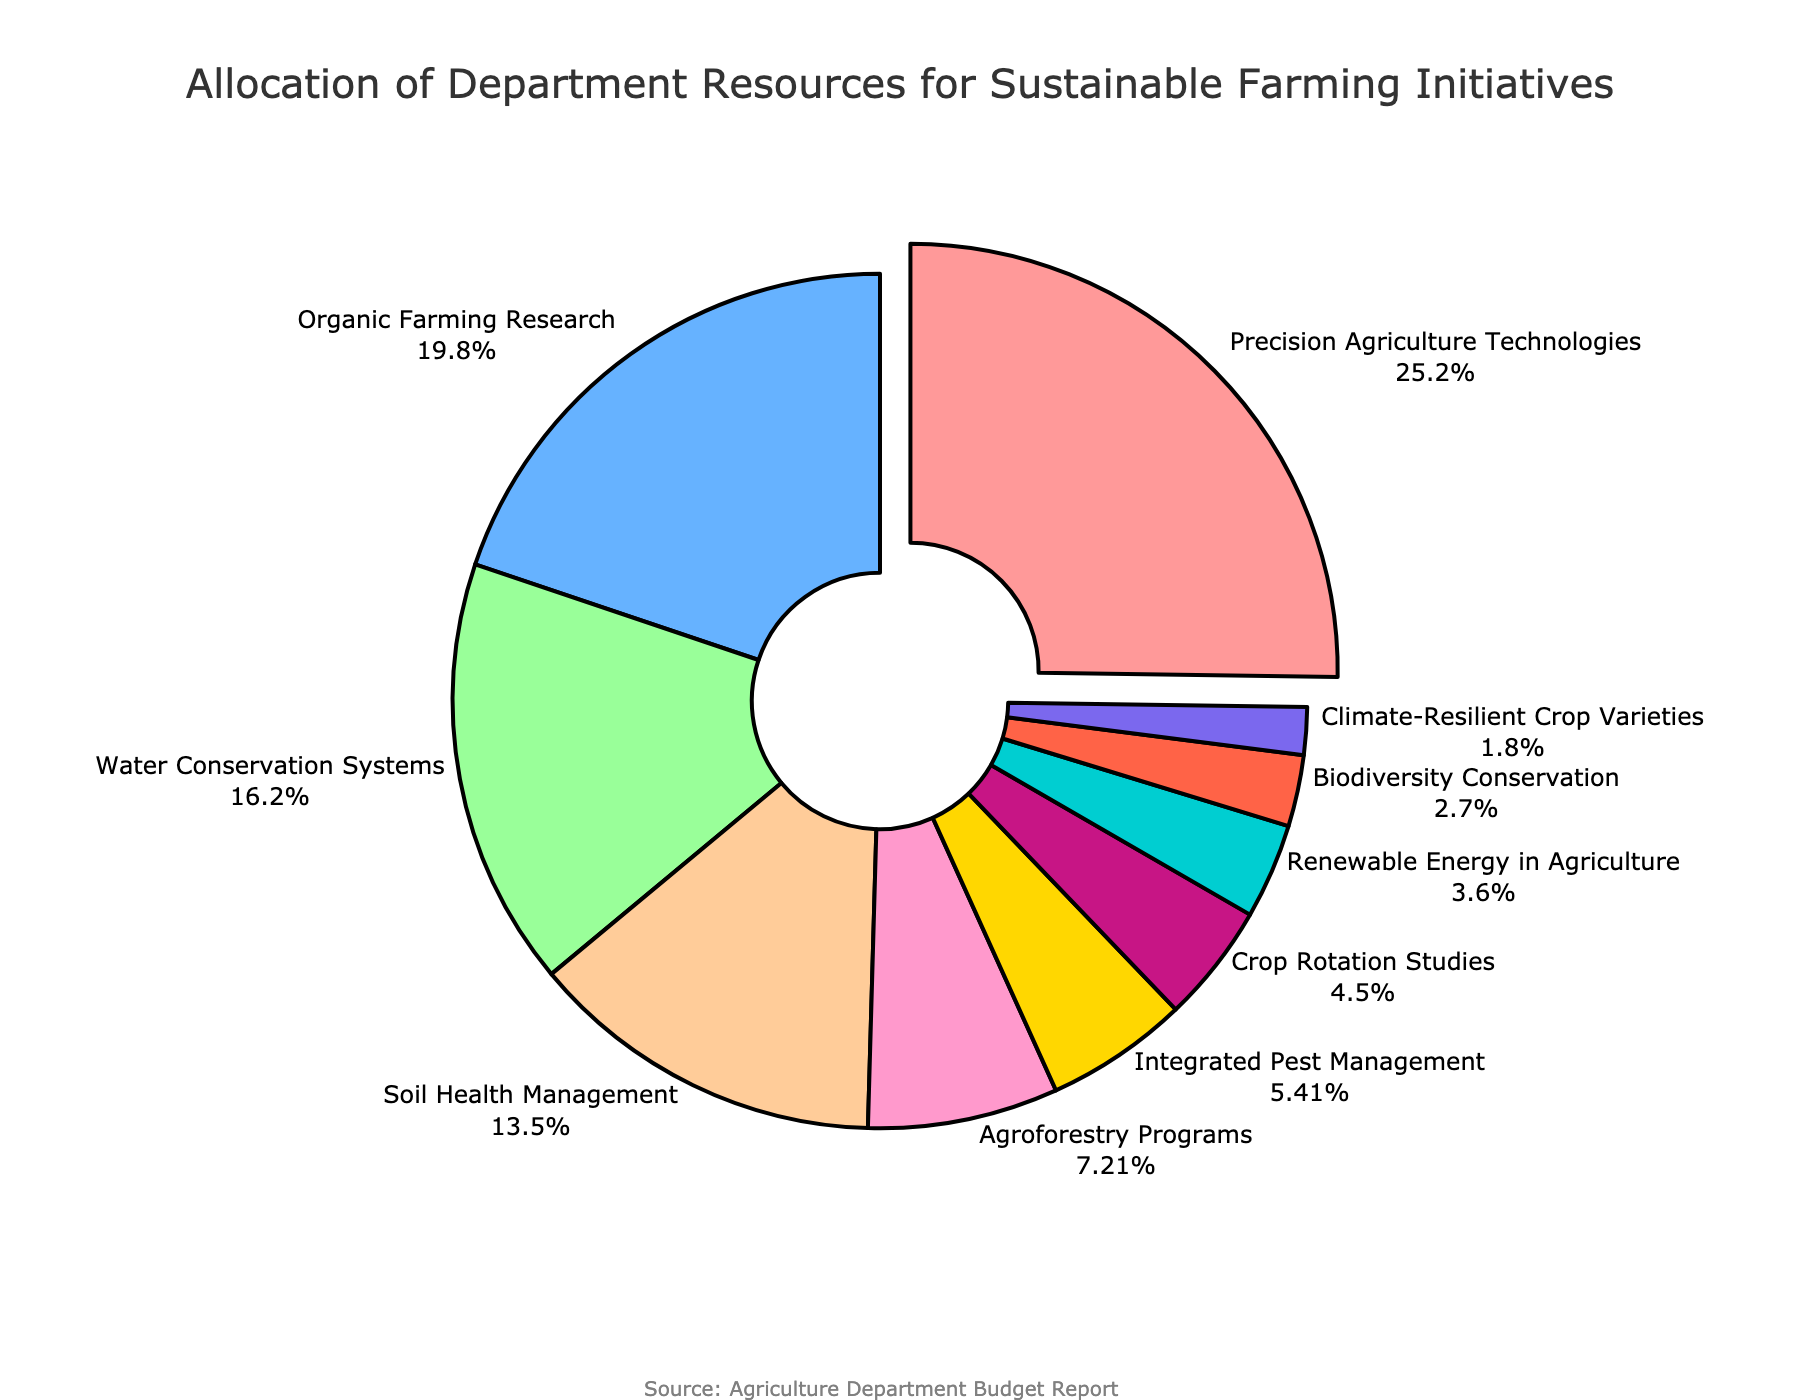What is the largest allocation of resources among the initiatives? Precision Agriculture Technologies has the largest allocation. This is indicated by the slice pulled out from the pie chart, which shows that it takes up 28% of the budget
Answer: Precision Agriculture Technologies Which initiative has the smallest allocation and what percentage does it get? Climate-Resilient Crop Varieties has the smallest allocation. This can be identified by the smallest slice in the pie chart, which shows it takes up 2% of the budget
Answer: Climate-Resilient Crop Varieties, 2% How much larger is the budget for Organic Farming Research compared to Integrated Pest Management? First, find the respective percentages from the pie chart: Organic Farming Research at 22% and Integrated Pest Management at 6%. The difference is calculated by subtracting 6% from 22%, which results in 16%
Answer: 16% If we combine the allocations for Crop Rotation Studies and Renewable Energy in Agriculture, what percentage of the budget is spent on these two initiatives? Look for the respective slices in the pie chart: Crop Rotation Studies at 5% and Renewable Energy in Agriculture at 4%. Adding these together: 5% + 4% = 9%
Answer: 9% What is the combined percentage of the budget allocated to the bottom three initiatives (Biodiversity Conservation, Climate-Resilient Crop Varieties, and Renewable Energy in Agriculture)? Find the respective allocations in the pie chart: Biodiversity Conservation at 3%, Climate-Resilient Crop Varieties at 2%, and Renewable Energy in Agriculture at 4%. Adding these together: 3% + 2% + 4% = 9%
Answer: 9% Which initiative takes up approximately one-quarter of the total budget? Precision Agriculture Technologies takes up 28% of the budget. A quarter of the budget would be 25%. Since 28% is close to 25%, Precision Agriculture Technologies is the initiative that takes up approximately one-quarter of the total budget
Answer: Precision Agriculture Technologies What is the combined budget allocation for Water Conservation Systems and Soil Health Management? Look at the respective percentages: Water Conservation Systems at 18% and Soil Health Management at 15%. Adding these together: 18% + 15% = 33%
Answer: 33% How does the budget allocation for Agroforestry Programs compare to that of Crop Rotation Studies? Agroforestry Programs receive 8% of the budget, while Crop Rotation Studies receive 5%. Therefore, Agroforestry Programs receive 3% more. This is evident by comparing the relative sizes of the slices on the pie chart
Answer: 3% more Which color represents Organic Farming Research, and what is its budget allocation percentage? Organic Farming Research is represented by a distinct color (e.g., light blue) and its budget allocation percentage from the pie chart is 22%
Answer: 22% What proportion does Soil Health Management hold in the pie chart compared to Biodiversity Conservation? Soil Health Management is at 15% while Biodiversity Conservation is at 3%. To find the proportion, divide 15% by 3%, which results in a 5:1 ratio
Answer: 5:1 